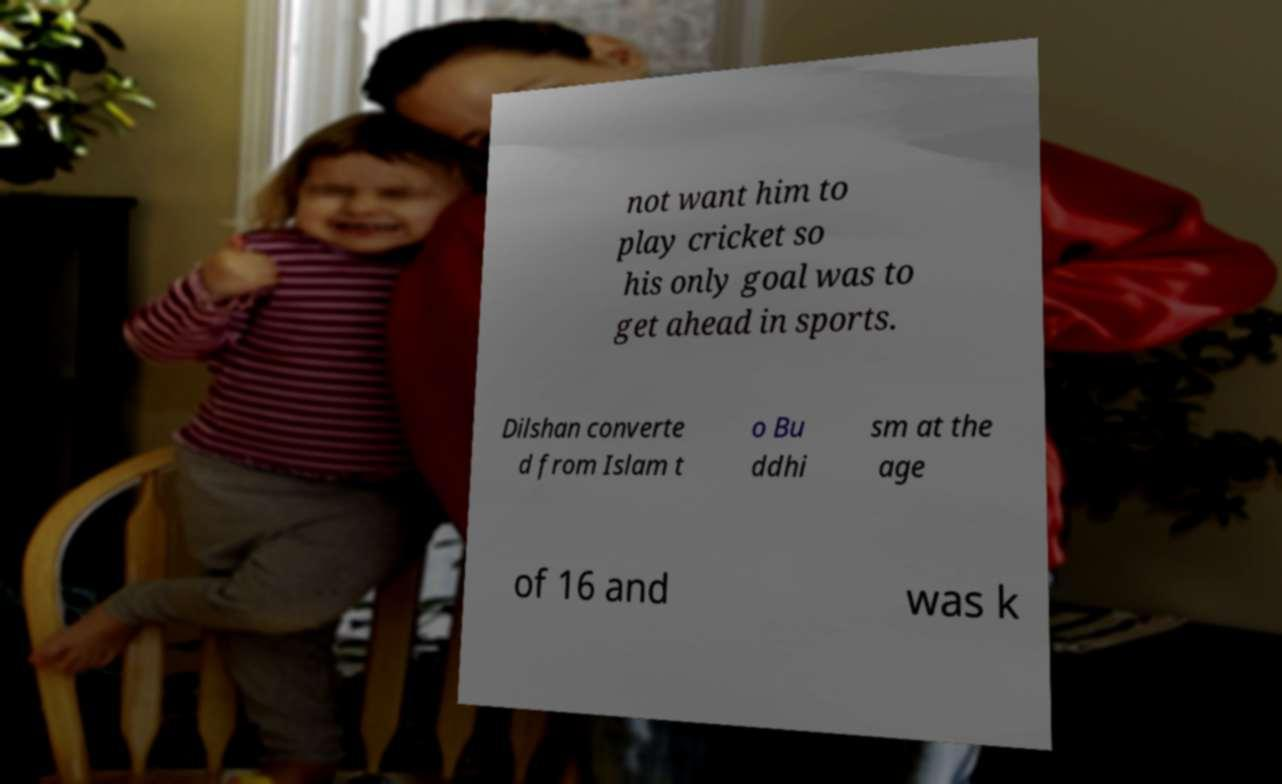Please identify and transcribe the text found in this image. not want him to play cricket so his only goal was to get ahead in sports. Dilshan converte d from Islam t o Bu ddhi sm at the age of 16 and was k 